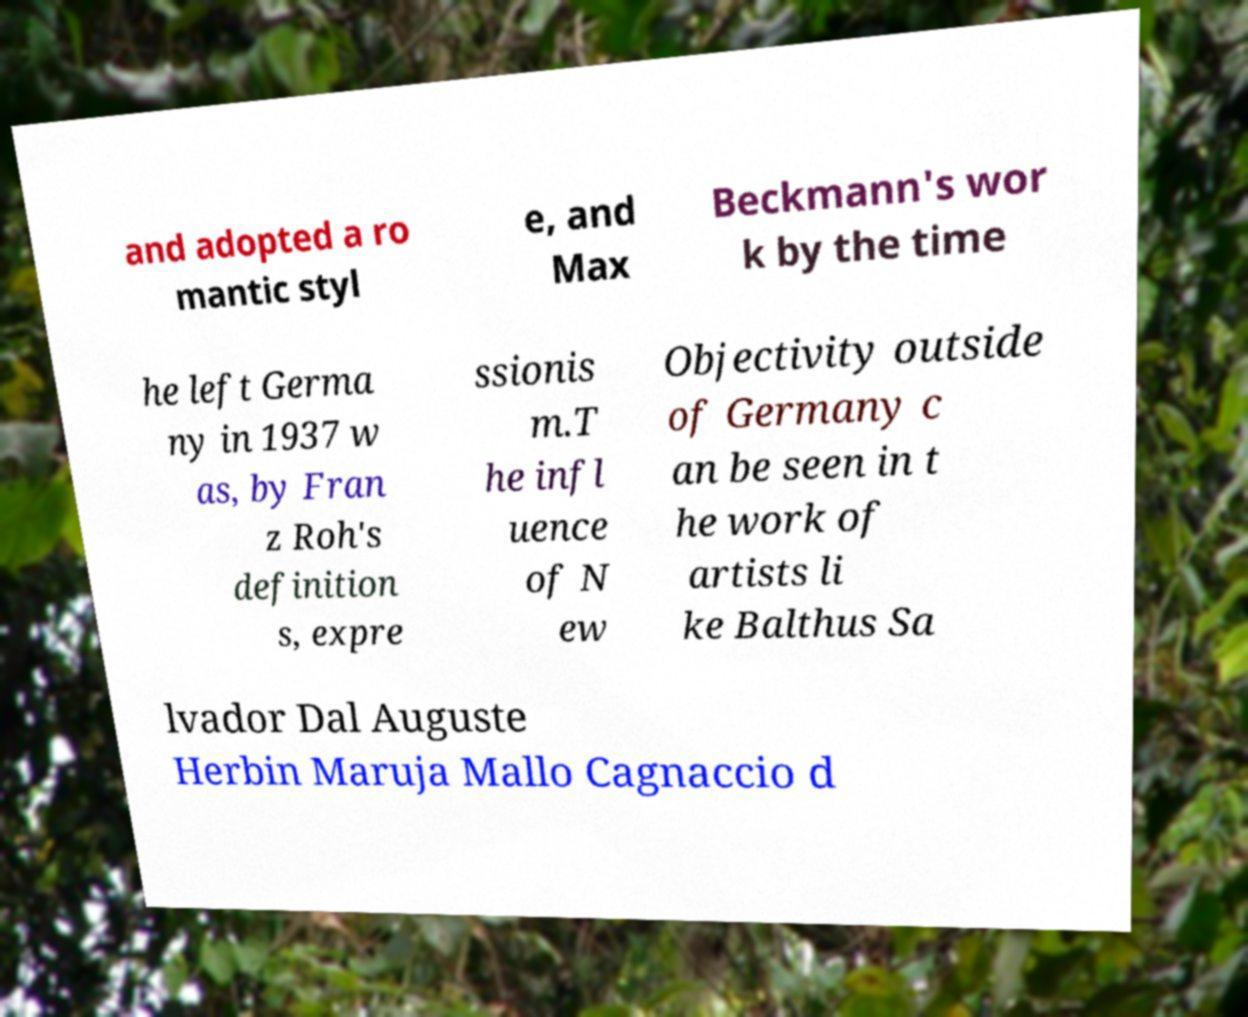What messages or text are displayed in this image? I need them in a readable, typed format. and adopted a ro mantic styl e, and Max Beckmann's wor k by the time he left Germa ny in 1937 w as, by Fran z Roh's definition s, expre ssionis m.T he infl uence of N ew Objectivity outside of Germany c an be seen in t he work of artists li ke Balthus Sa lvador Dal Auguste Herbin Maruja Mallo Cagnaccio d 